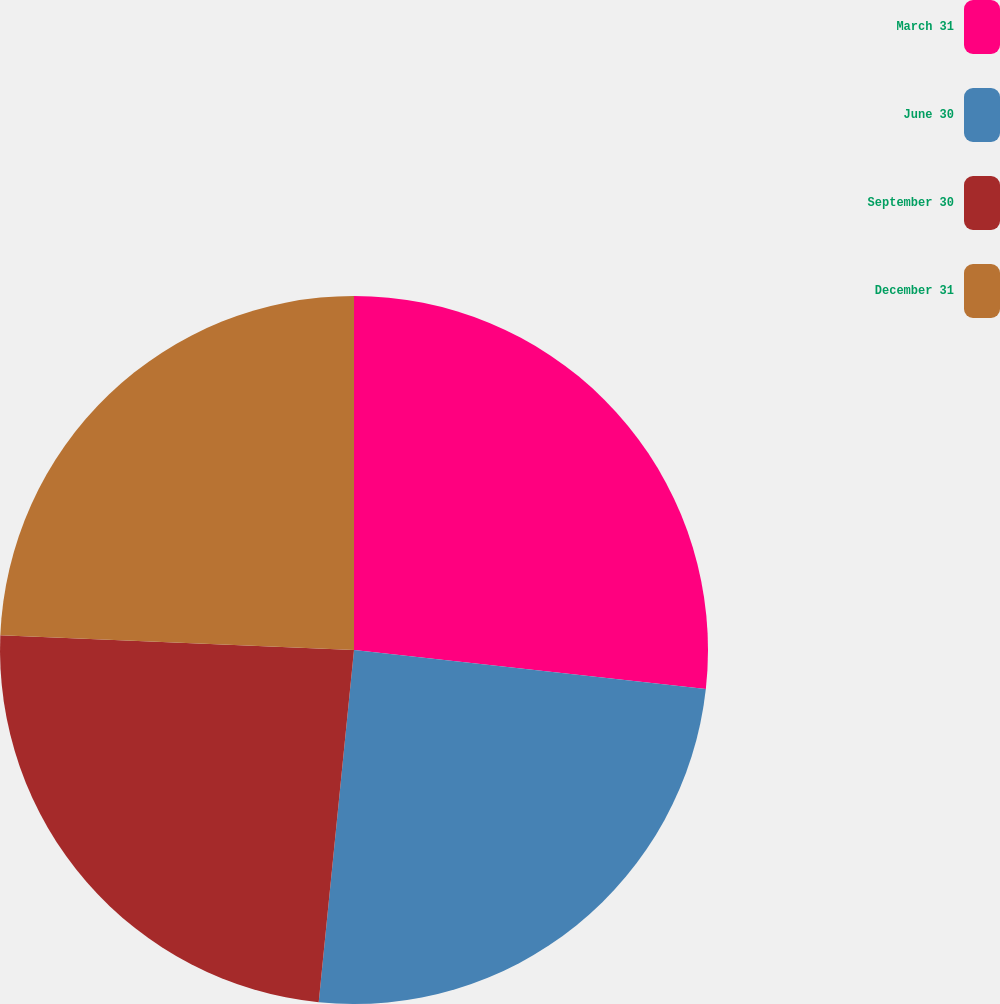Convert chart to OTSL. <chart><loc_0><loc_0><loc_500><loc_500><pie_chart><fcel>March 31<fcel>June 30<fcel>September 30<fcel>December 31<nl><fcel>26.76%<fcel>24.83%<fcel>24.07%<fcel>24.34%<nl></chart> 